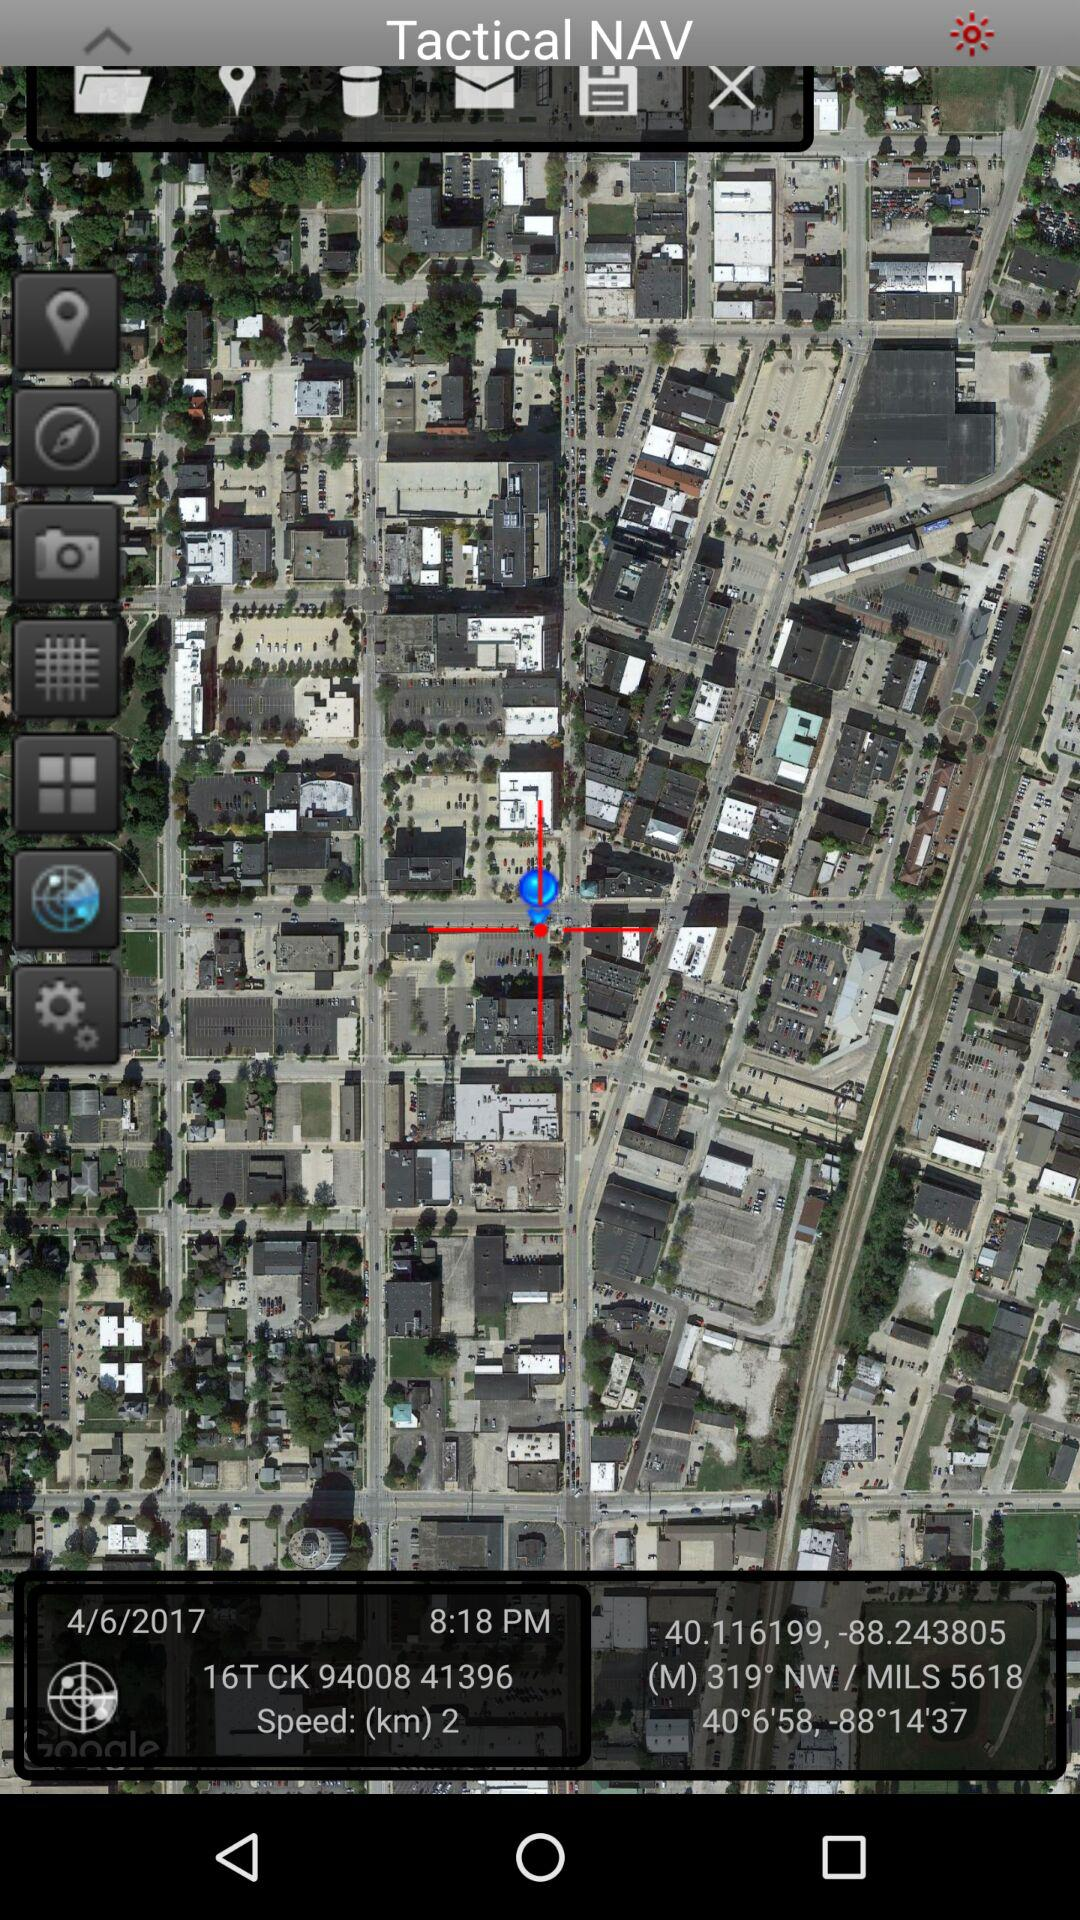What are the coordinates? The coordinates are 40.116199, -88.243805 and 40° 6' 58", -88° 14' 37". 